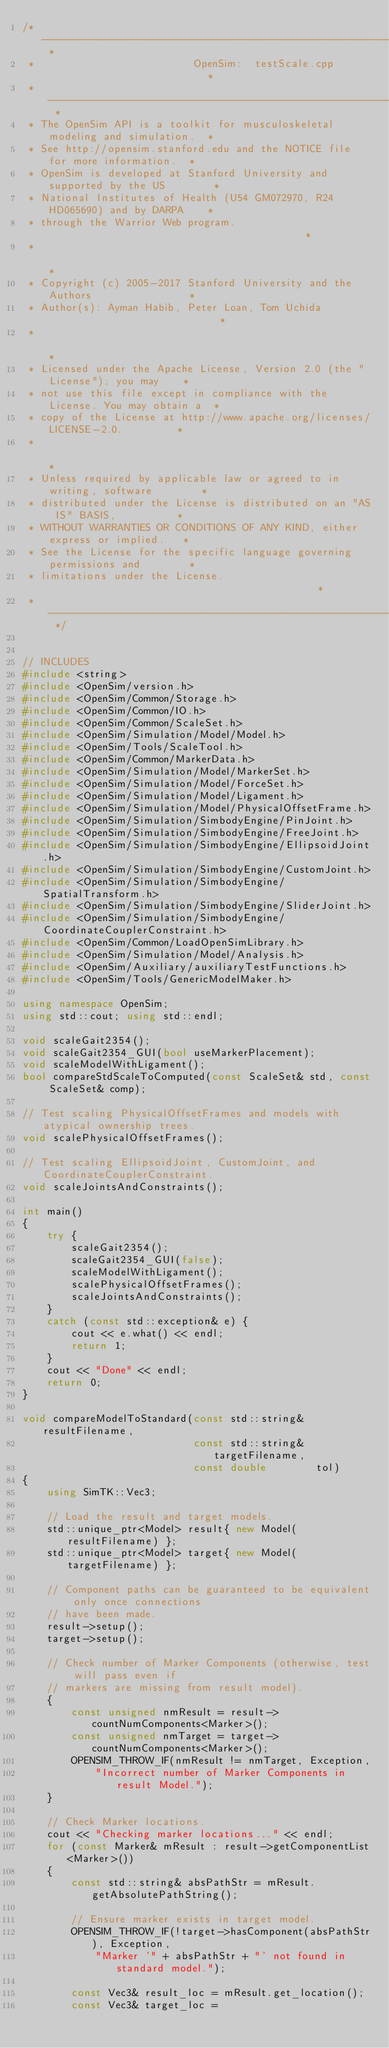Convert code to text. <code><loc_0><loc_0><loc_500><loc_500><_C++_>/* -------------------------------------------------------------------------- *
 *                          OpenSim:  testScale.cpp                           *
 * -------------------------------------------------------------------------- *
 * The OpenSim API is a toolkit for musculoskeletal modeling and simulation.  *
 * See http://opensim.stanford.edu and the NOTICE file for more information.  *
 * OpenSim is developed at Stanford University and supported by the US        *
 * National Institutes of Health (U54 GM072970, R24 HD065690) and by DARPA    *
 * through the Warrior Web program.                                           *
 *                                                                            *
 * Copyright (c) 2005-2017 Stanford University and the Authors                *
 * Author(s): Ayman Habib, Peter Loan, Tom Uchida                             *
 *                                                                            *
 * Licensed under the Apache License, Version 2.0 (the "License"); you may    *
 * not use this file except in compliance with the License. You may obtain a  *
 * copy of the License at http://www.apache.org/licenses/LICENSE-2.0.         *
 *                                                                            *
 * Unless required by applicable law or agreed to in writing, software        *
 * distributed under the License is distributed on an "AS IS" BASIS,          *
 * WITHOUT WARRANTIES OR CONDITIONS OF ANY KIND, either express or implied.   *
 * See the License for the specific language governing permissions and        *
 * limitations under the License.                                             *
 * -------------------------------------------------------------------------- */


// INCLUDES
#include <string>
#include <OpenSim/version.h>
#include <OpenSim/Common/Storage.h>
#include <OpenSim/Common/IO.h>
#include <OpenSim/Common/ScaleSet.h>
#include <OpenSim/Simulation/Model/Model.h>
#include <OpenSim/Tools/ScaleTool.h>
#include <OpenSim/Common/MarkerData.h>
#include <OpenSim/Simulation/Model/MarkerSet.h>
#include <OpenSim/Simulation/Model/ForceSet.h>
#include <OpenSim/Simulation/Model/Ligament.h>
#include <OpenSim/Simulation/Model/PhysicalOffsetFrame.h>
#include <OpenSim/Simulation/SimbodyEngine/PinJoint.h>
#include <OpenSim/Simulation/SimbodyEngine/FreeJoint.h>
#include <OpenSim/Simulation/SimbodyEngine/EllipsoidJoint.h>
#include <OpenSim/Simulation/SimbodyEngine/CustomJoint.h>
#include <OpenSim/Simulation/SimbodyEngine/SpatialTransform.h>
#include <OpenSim/Simulation/SimbodyEngine/SliderJoint.h>
#include <OpenSim/Simulation/SimbodyEngine/CoordinateCouplerConstraint.h>
#include <OpenSim/Common/LoadOpenSimLibrary.h>
#include <OpenSim/Simulation/Model/Analysis.h>
#include <OpenSim/Auxiliary/auxiliaryTestFunctions.h>
#include <OpenSim/Tools/GenericModelMaker.h>

using namespace OpenSim;
using std::cout; using std::endl;

void scaleGait2354();
void scaleGait2354_GUI(bool useMarkerPlacement);
void scaleModelWithLigament();
bool compareStdScaleToComputed(const ScaleSet& std, const ScaleSet& comp);

// Test scaling PhysicalOffsetFrames and models with atypical ownership trees.
void scalePhysicalOffsetFrames();

// Test scaling EllipsoidJoint, CustomJoint, and CoordinateCouplerConstraint.
void scaleJointsAndConstraints();

int main()
{
    try {
        scaleGait2354();
        scaleGait2354_GUI(false);
        scaleModelWithLigament();
        scalePhysicalOffsetFrames();
        scaleJointsAndConstraints();
    }
    catch (const std::exception& e) {
        cout << e.what() << endl;
        return 1;
    }
    cout << "Done" << endl;
    return 0;
}

void compareModelToStandard(const std::string&  resultFilename,
                            const std::string&  targetFilename,
                            const double        tol)
{
    using SimTK::Vec3;

    // Load the result and target models.
    std::unique_ptr<Model> result{ new Model(resultFilename) };
    std::unique_ptr<Model> target{ new Model(targetFilename) };

    // Component paths can be guaranteed to be equivalent only once connections
    // have been made.
    result->setup();
    target->setup();

    // Check number of Marker Components (otherwise, test will pass even if
    // markers are missing from result model).
    {
        const unsigned nmResult = result->countNumComponents<Marker>();
        const unsigned nmTarget = target->countNumComponents<Marker>();
        OPENSIM_THROW_IF(nmResult != nmTarget, Exception,
            "Incorrect number of Marker Components in result Model.");
    }

    // Check Marker locations.
    cout << "Checking marker locations..." << endl;
    for (const Marker& mResult : result->getComponentList<Marker>())
    {
        const std::string& absPathStr = mResult.getAbsolutePathString();

        // Ensure marker exists in target model.
        OPENSIM_THROW_IF(!target->hasComponent(absPathStr), Exception,
            "Marker '" + absPathStr + "' not found in standard model.");

        const Vec3& result_loc = mResult.get_location();
        const Vec3& target_loc =</code> 